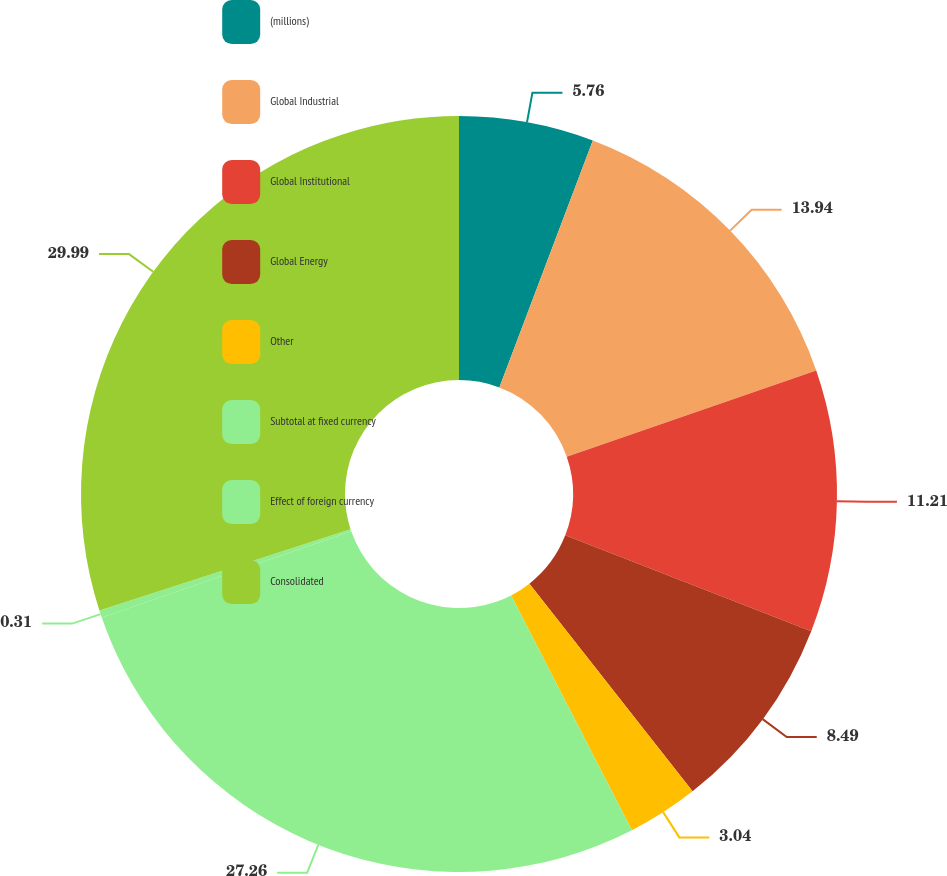<chart> <loc_0><loc_0><loc_500><loc_500><pie_chart><fcel>(millions)<fcel>Global Industrial<fcel>Global Institutional<fcel>Global Energy<fcel>Other<fcel>Subtotal at fixed currency<fcel>Effect of foreign currency<fcel>Consolidated<nl><fcel>5.76%<fcel>13.94%<fcel>11.21%<fcel>8.49%<fcel>3.04%<fcel>27.26%<fcel>0.31%<fcel>29.99%<nl></chart> 